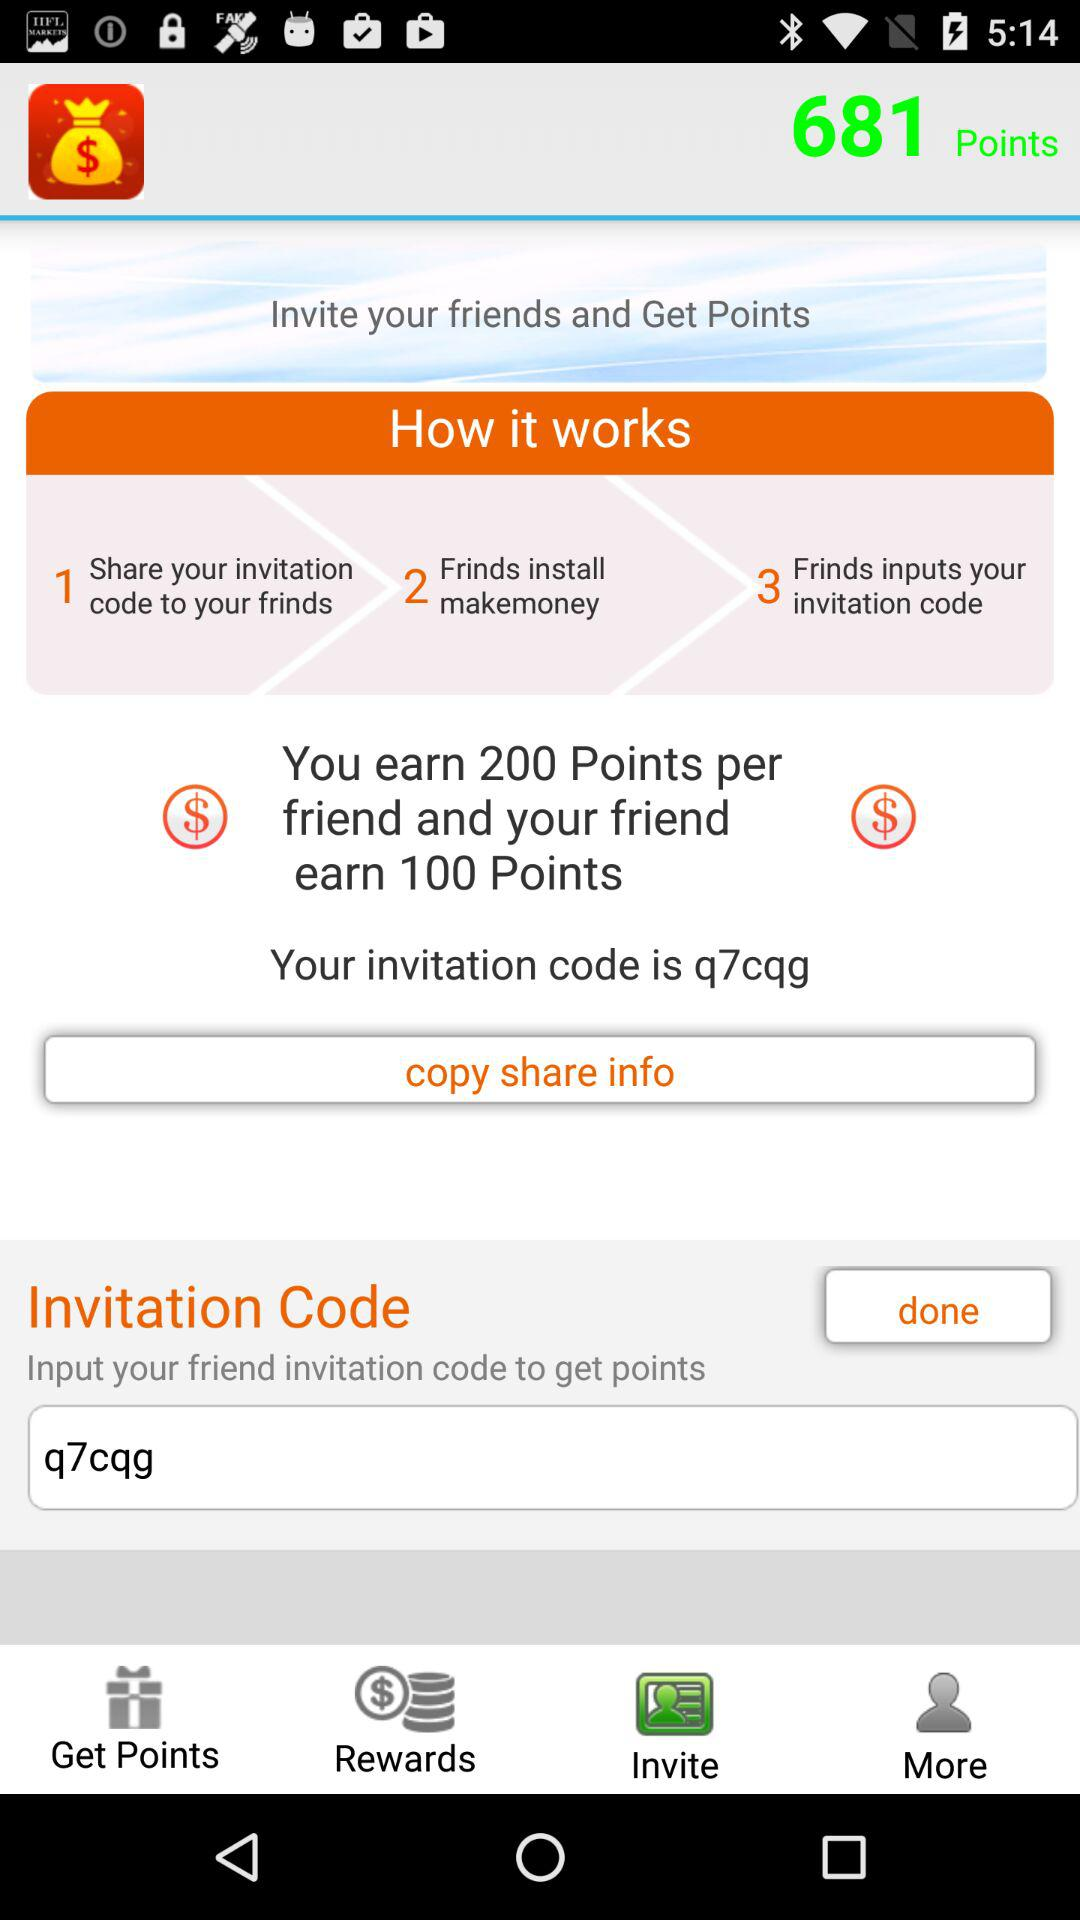How many points do I earn if I invite 3 friends?
Answer the question using a single word or phrase. 600 